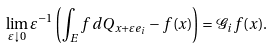Convert formula to latex. <formula><loc_0><loc_0><loc_500><loc_500>\lim _ { { \varepsilon } \downarrow 0 } { \varepsilon } ^ { - 1 } \left ( \int _ { E } f \, d Q _ { x + { \varepsilon } e _ { i } } - f ( x ) \right ) = { \mathcal { G } } _ { i } f ( x ) .</formula> 